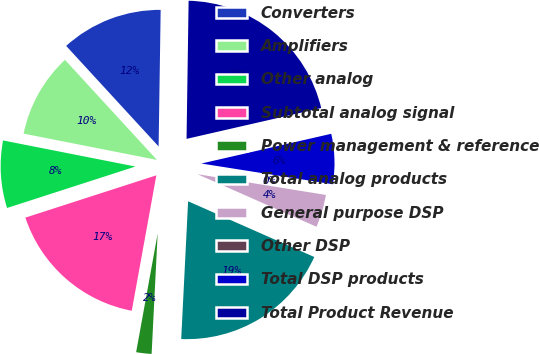Convert chart to OTSL. <chart><loc_0><loc_0><loc_500><loc_500><pie_chart><fcel>Converters<fcel>Amplifiers<fcel>Other analog<fcel>Subtotal analog signal<fcel>Power management & reference<fcel>Total analog products<fcel>General purpose DSP<fcel>Other DSP<fcel>Total DSP products<fcel>Total Product Revenue<nl><fcel>12.07%<fcel>10.07%<fcel>8.07%<fcel>17.17%<fcel>2.06%<fcel>19.18%<fcel>4.07%<fcel>0.06%<fcel>6.07%<fcel>21.18%<nl></chart> 